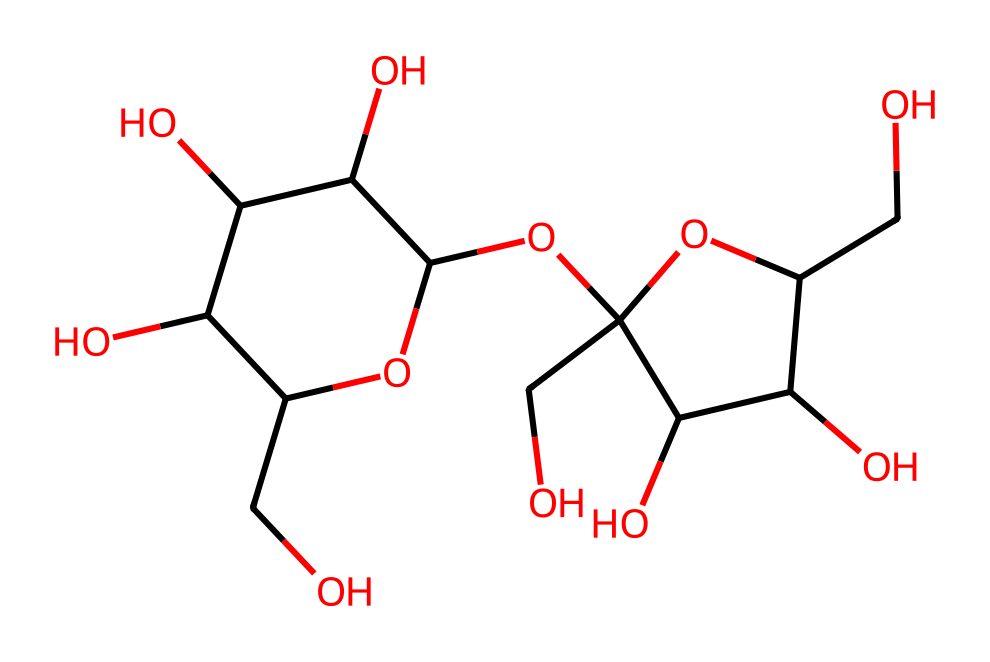What is the main component of this sugar cube crystal? The SMILES representation shows multiple carbon atoms bonded with oxygen and hydrogen. This indicates the structure is primarily composed of sugar molecules, specifically showing multiple hydroxyl (–OH) groups, characteristic of carbohydrates.
Answer: sugar How many carbon atoms are in this structure? By analyzing the SMILES representation, we can count the number of 'C' characters, which indicates the carbon atoms. There are 12 'C' characters present, showing that there are 12 carbon atoms in the structure.
Answer: 12 What type of bonding is present in the sugar cube crystal? The SMILES structure reflects multiple carbon and oxygen atoms bonded through covalent bonds. The connections between the atoms represent stable covalent bonds typical in carbohydrate structures, particularly those found in sugars.
Answer: covalent bonds What is the total number of hydroxyl groups (–OH) in this compound? As you look through the structure represented by the SMILES, one can count the number of ‘O’ atoms that are directly attached to hydrogen atoms. This compound has 6 hydroxyl groups, which are characteristic of many sugars, giving them their sweet taste and solubility in water.
Answer: 6 Is this compound a cage compound? The structure exhibits a cyclic arrangement of carbon atoms with several hydroxyl groups attached, fitting the definition of a cage compound, which has a closed, cage-like structure in molecular geometry.
Answer: yes 